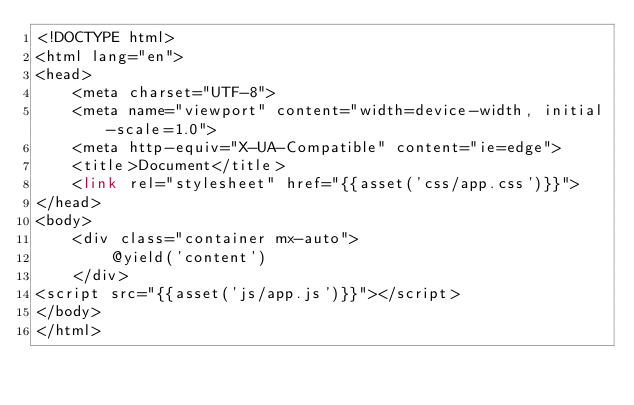Convert code to text. <code><loc_0><loc_0><loc_500><loc_500><_PHP_><!DOCTYPE html>
<html lang="en">
<head>
    <meta charset="UTF-8">
    <meta name="viewport" content="width=device-width, initial-scale=1.0">
    <meta http-equiv="X-UA-Compatible" content="ie=edge">
    <title>Document</title>
    <link rel="stylesheet" href="{{asset('css/app.css')}}">
</head>
<body>
    <div class="container mx-auto">
        @yield('content')
    </div>
<script src="{{asset('js/app.js')}}"></script>
</body>
</html>
</code> 